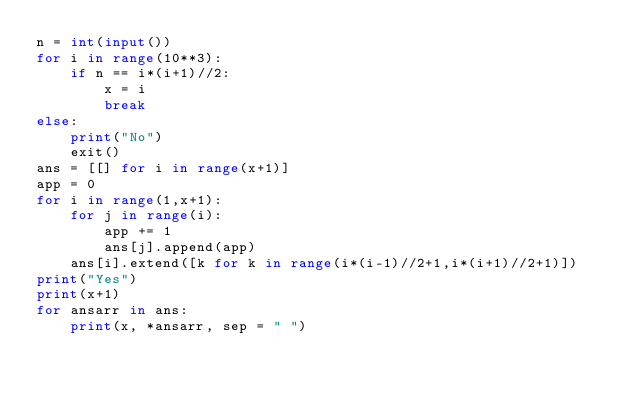<code> <loc_0><loc_0><loc_500><loc_500><_Python_>n = int(input())
for i in range(10**3):
    if n == i*(i+1)//2:
        x = i
        break
else:
    print("No")
    exit()
ans = [[] for i in range(x+1)]
app = 0
for i in range(1,x+1):
    for j in range(i):
        app += 1
        ans[j].append(app)
    ans[i].extend([k for k in range(i*(i-1)//2+1,i*(i+1)//2+1)])
print("Yes")
print(x+1)
for ansarr in ans:
    print(x, *ansarr, sep = " ")</code> 